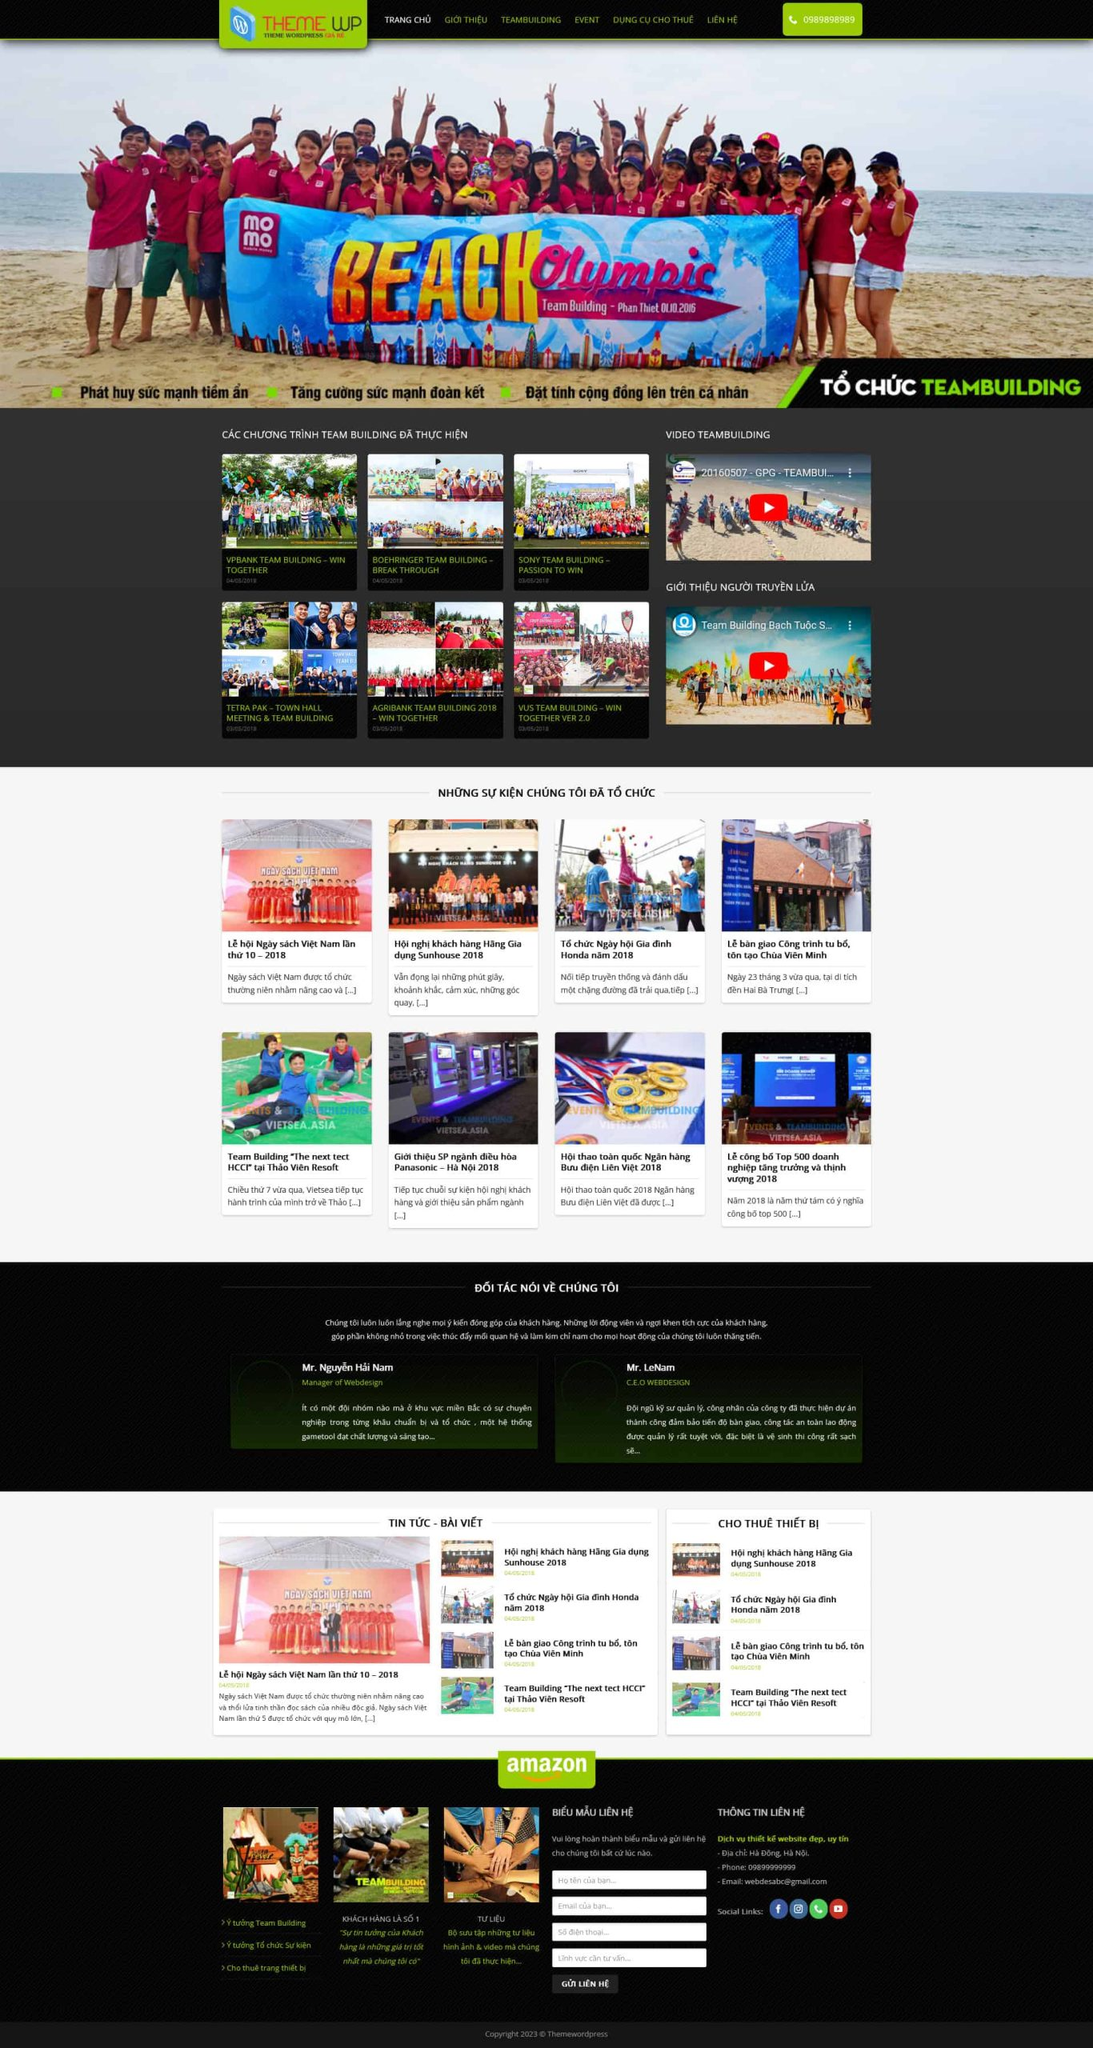Liệt kê 5 ngành nghề, lĩnh vực phù hợp với website này, phân cách các màu sắc bằng dấu phẩy. Chỉ trả về kết quả, phân cách bằng dấy phẩy
 Tổ chức team building, Sự kiện, Truyền thông, Đào tạo kỹ năng mềm, Du lịch doanh nghiệp 